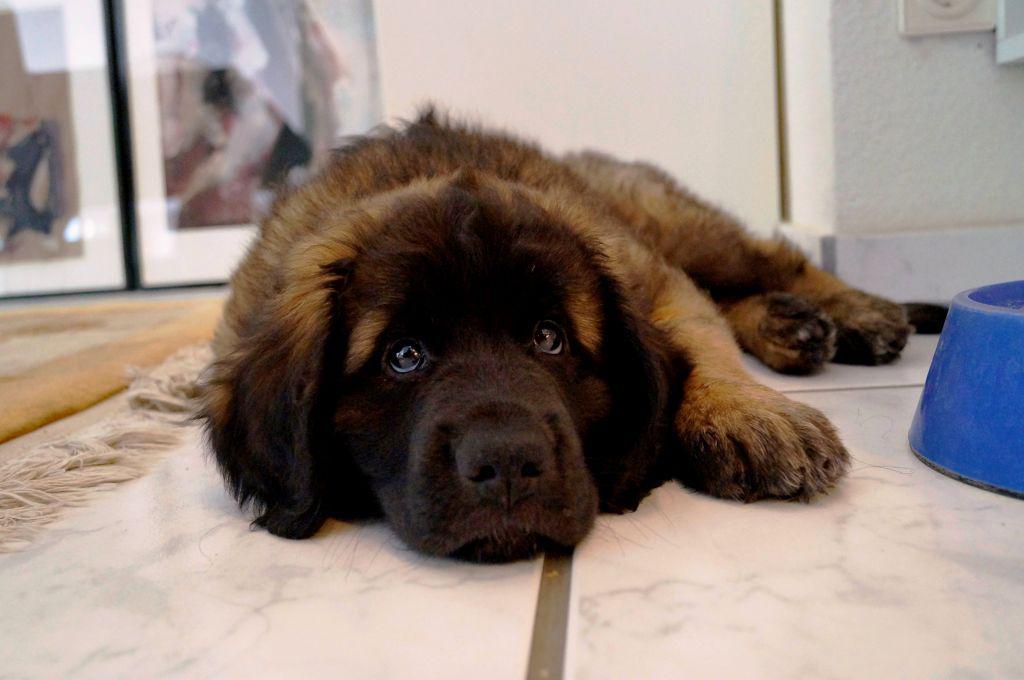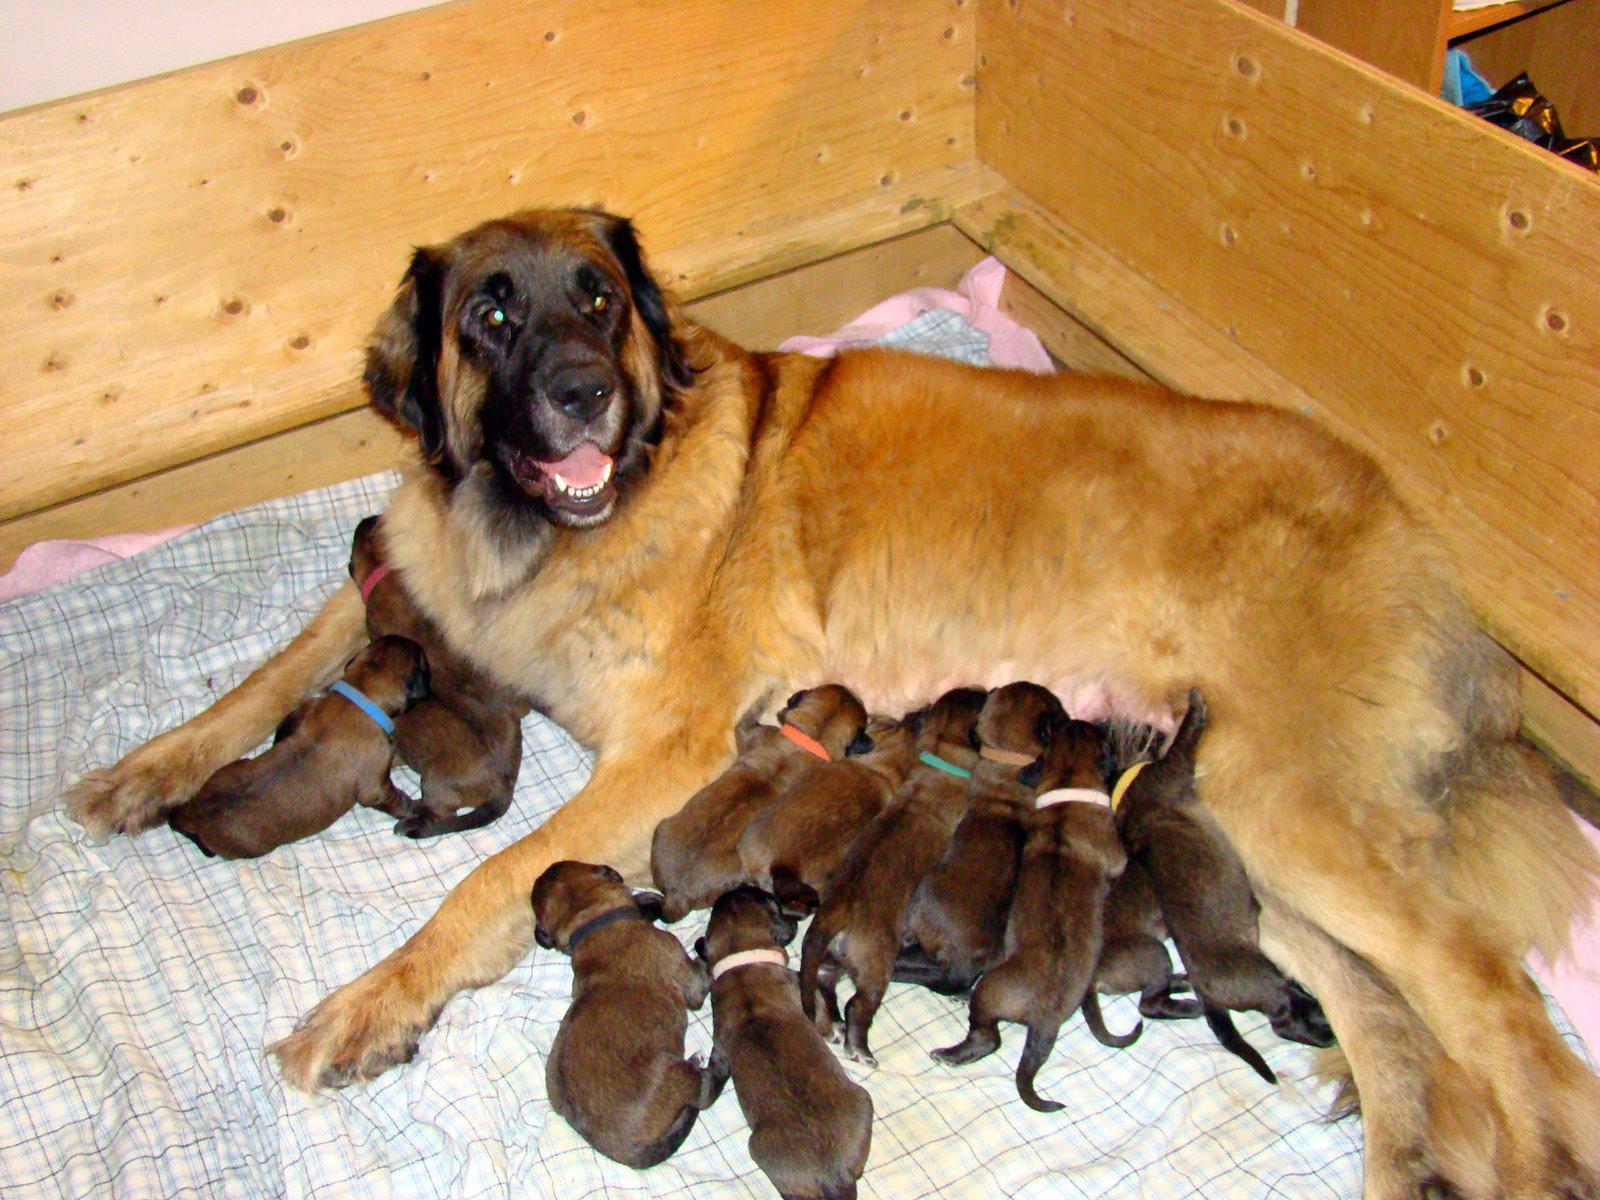The first image is the image on the left, the second image is the image on the right. Considering the images on both sides, is "An adult dog is lying on her side with front legs extended outward while her puppies crowd in to nurse, while a second image shows a large dog lying on a floor." valid? Answer yes or no. Yes. 